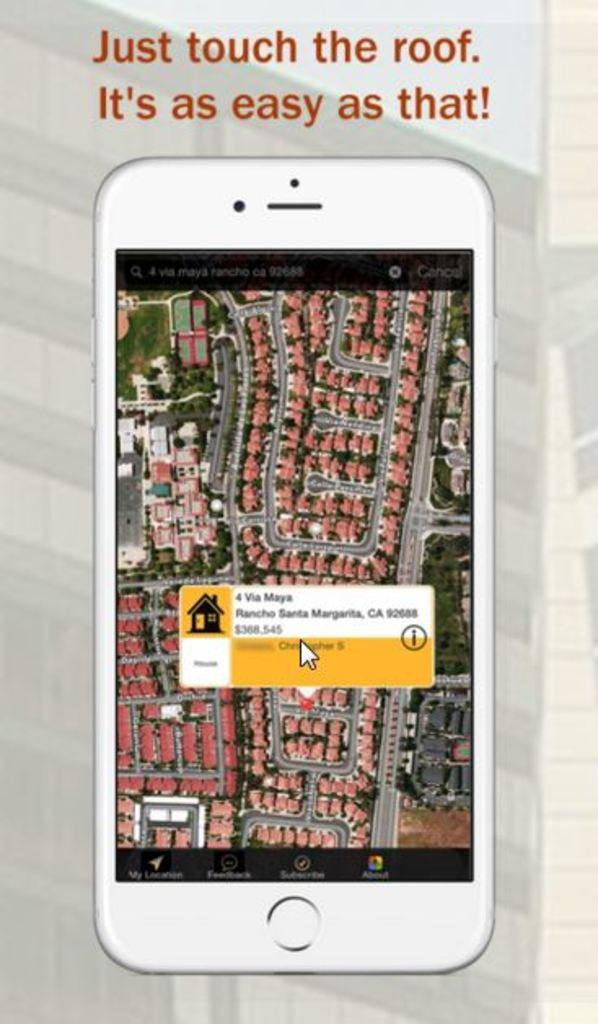<image>
Create a compact narrative representing the image presented. A poster displays a phone and the message "just touch the roof. It's as easy as that!" 